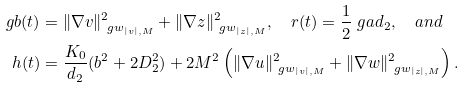Convert formula to latex. <formula><loc_0><loc_0><loc_500><loc_500>\ g b ( t ) & = \| \nabla v \| _ { \ g w _ { | v | , M } } ^ { 2 } + \| \nabla z \| _ { \ g w _ { | z | , M } } ^ { 2 } , \quad r ( t ) = \frac { 1 } { 2 } \ g a d _ { 2 } , \quad a n d \\ h ( t ) & = \frac { K _ { 0 } } { d _ { 2 } } ( b ^ { 2 } + 2 D _ { 2 } ^ { 2 } ) + 2 M ^ { 2 } \left ( \| \nabla u \| _ { \ g w _ { | v | , M } } ^ { 2 } + \| \nabla w \| _ { \ g w _ { | z | , M } } ^ { 2 } \right ) .</formula> 